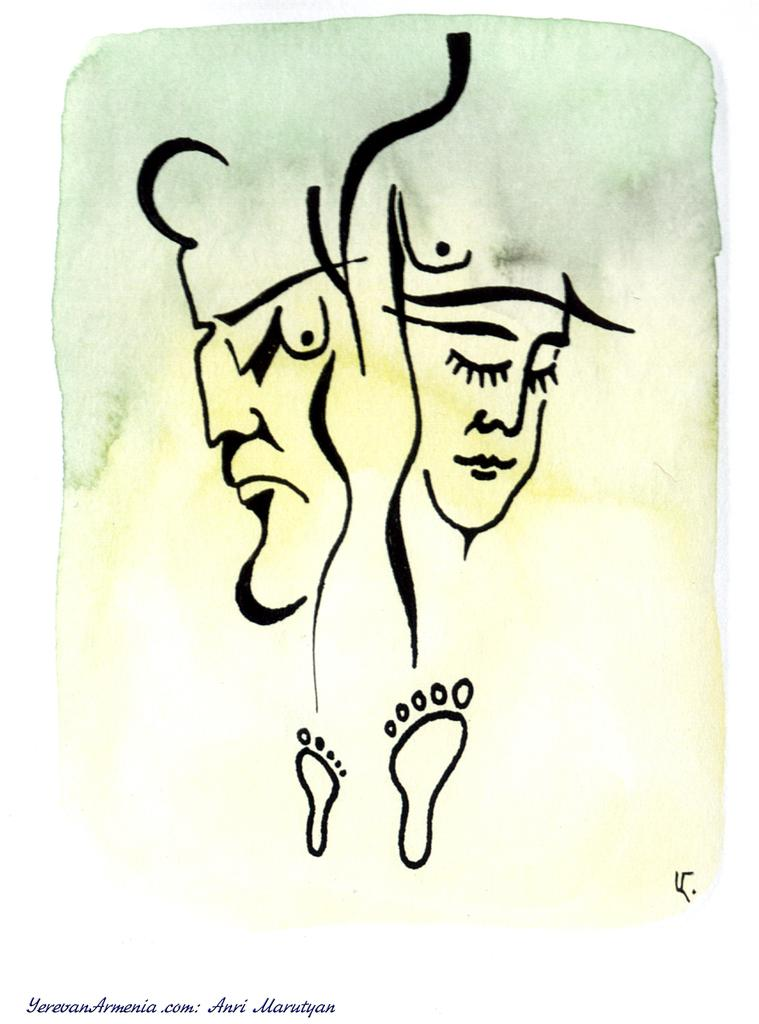What type of sketches can be seen in the image? There is a sketch of human faces and a sketch of human feet in the image. What is the medium for these sketches? The sketches are on a piece of paper. Is there any text present in the image? Yes, there is text in the left bottom corner of the image. What type of quince is depicted in the image? There is no quince present in the image; it features sketches of human faces and feet on a piece of paper. How does the rose look in the image? There is no rose present in the image. 